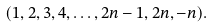Convert formula to latex. <formula><loc_0><loc_0><loc_500><loc_500>( 1 , 2 , 3 , 4 , \dots , 2 n - 1 , 2 n , - n ) .</formula> 